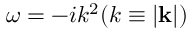Convert formula to latex. <formula><loc_0><loc_0><loc_500><loc_500>\omega = - i k ^ { 2 } ( k \equiv | k | )</formula> 